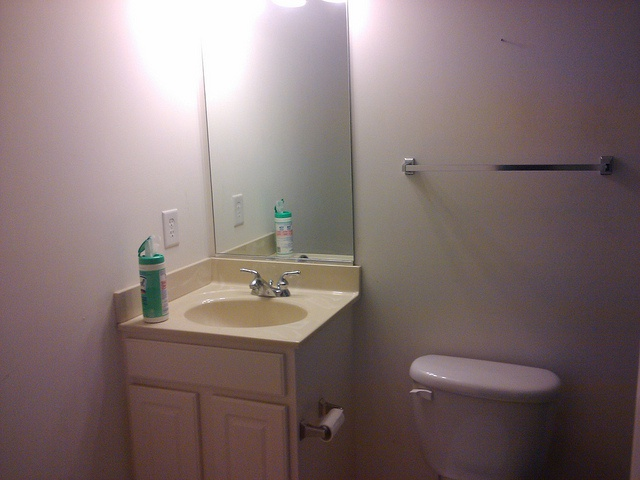Describe the objects in this image and their specific colors. I can see toilet in gray, black, and purple tones and sink in gray and tan tones in this image. 